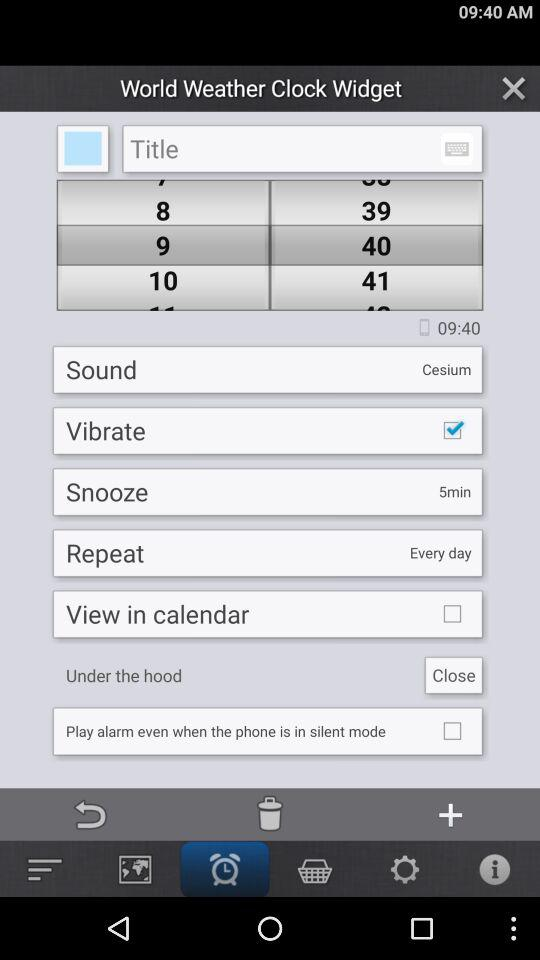What is the status of "Vibrate"? The status is "on". 